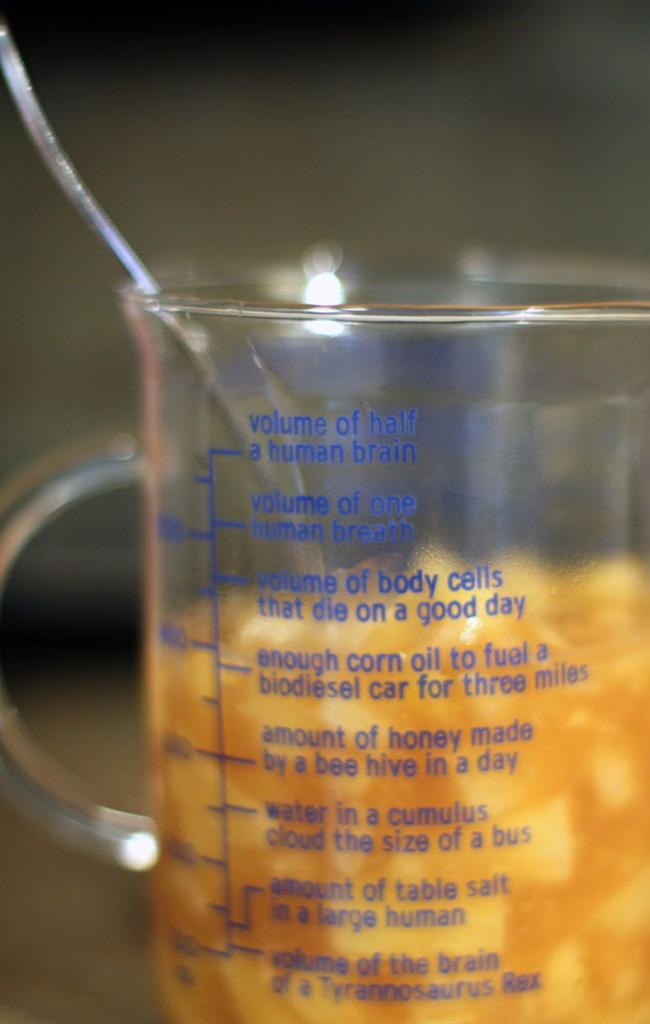<image>
Provide a brief description of the given image. A measuring cup includes marker lines for the volume of half a human brain and the amount of honey made in a bee hive in a day. 